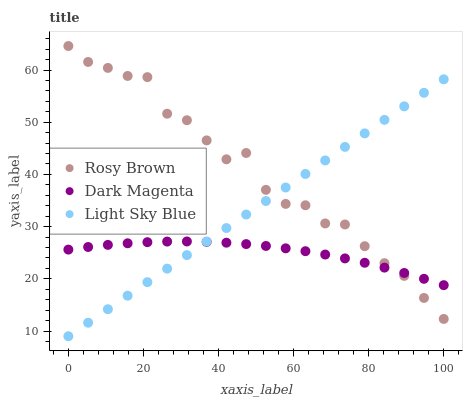Does Dark Magenta have the minimum area under the curve?
Answer yes or no. Yes. Does Rosy Brown have the maximum area under the curve?
Answer yes or no. Yes. Does Light Sky Blue have the minimum area under the curve?
Answer yes or no. No. Does Light Sky Blue have the maximum area under the curve?
Answer yes or no. No. Is Light Sky Blue the smoothest?
Answer yes or no. Yes. Is Rosy Brown the roughest?
Answer yes or no. Yes. Is Dark Magenta the smoothest?
Answer yes or no. No. Is Dark Magenta the roughest?
Answer yes or no. No. Does Light Sky Blue have the lowest value?
Answer yes or no. Yes. Does Dark Magenta have the lowest value?
Answer yes or no. No. Does Rosy Brown have the highest value?
Answer yes or no. Yes. Does Light Sky Blue have the highest value?
Answer yes or no. No. Does Rosy Brown intersect Light Sky Blue?
Answer yes or no. Yes. Is Rosy Brown less than Light Sky Blue?
Answer yes or no. No. Is Rosy Brown greater than Light Sky Blue?
Answer yes or no. No. 